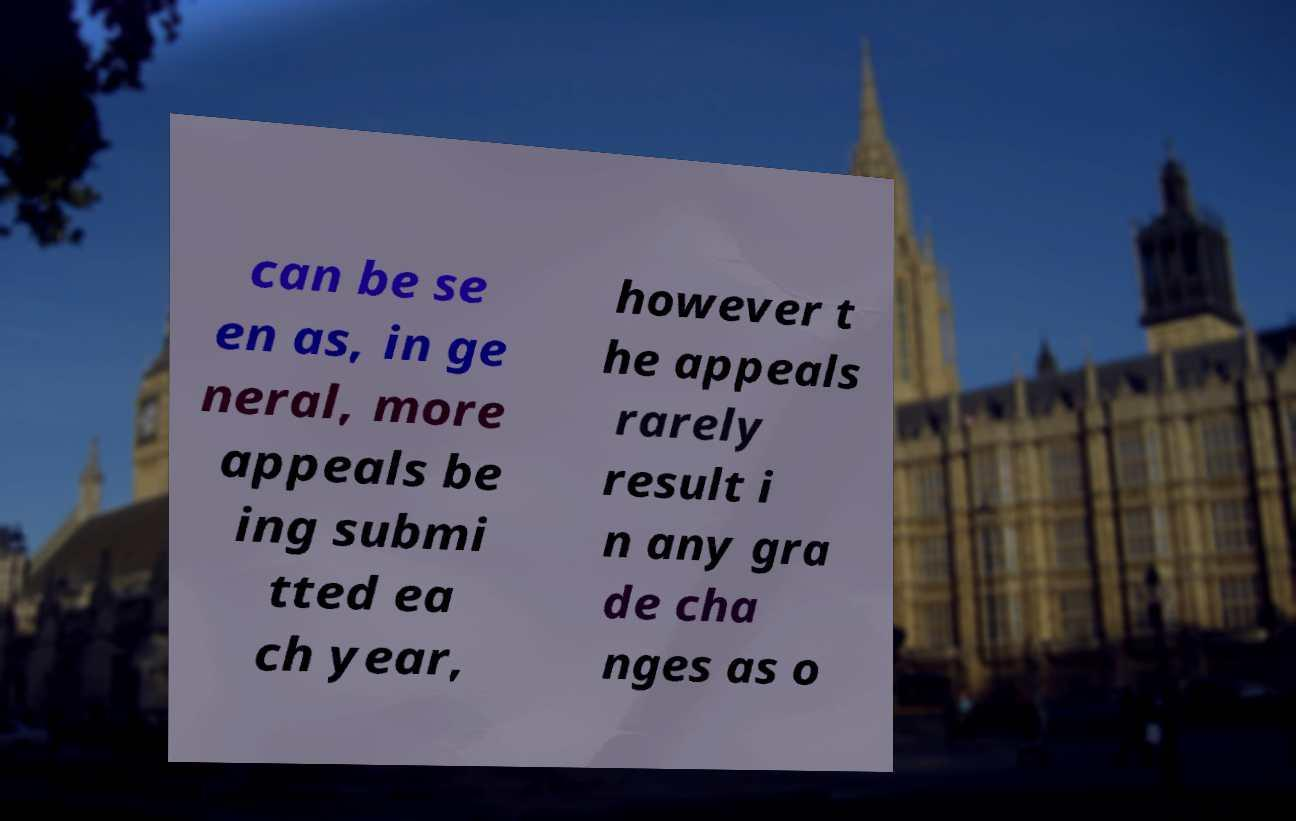Can you read and provide the text displayed in the image?This photo seems to have some interesting text. Can you extract and type it out for me? can be se en as, in ge neral, more appeals be ing submi tted ea ch year, however t he appeals rarely result i n any gra de cha nges as o 